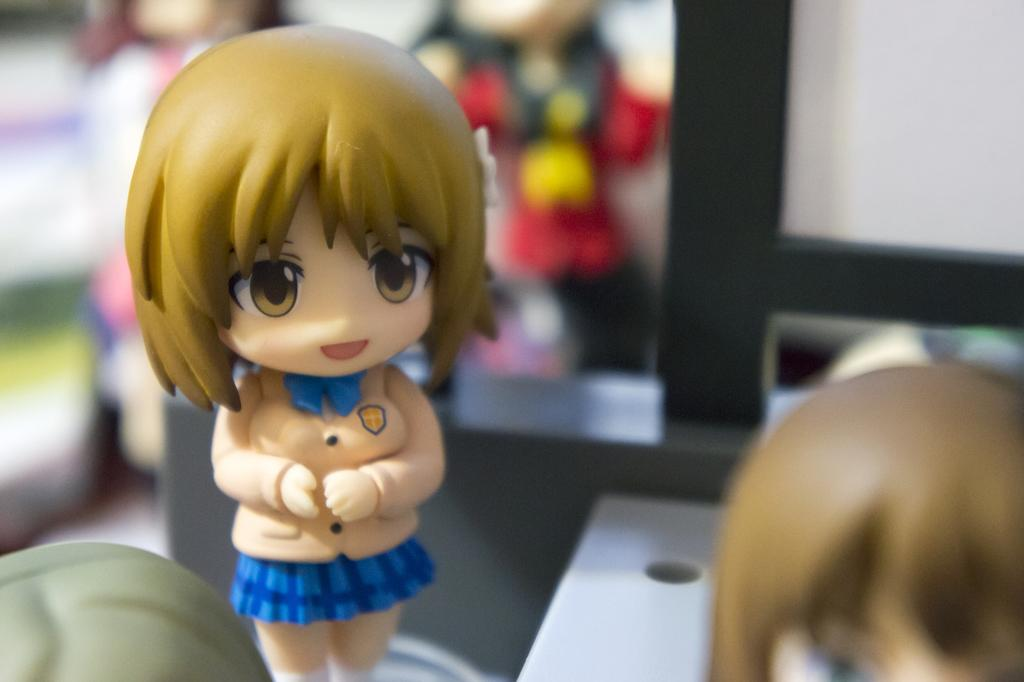What is the main subject of the image? There is a toy doll in the image. What is the toy doll wearing? The toy doll is wearing a cream and blue color dress. Are there any accessories on the toy doll? Yes, the toy doll has a blue bow. Can you describe the quality of the image? The back side of the image is blurry. How does the toy doll hear sounds in the image? The toy doll does not have the ability to hear sounds, as it is an inanimate object. 